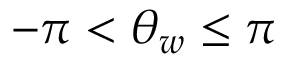<formula> <loc_0><loc_0><loc_500><loc_500>- \pi < \theta _ { w } \leq \pi</formula> 